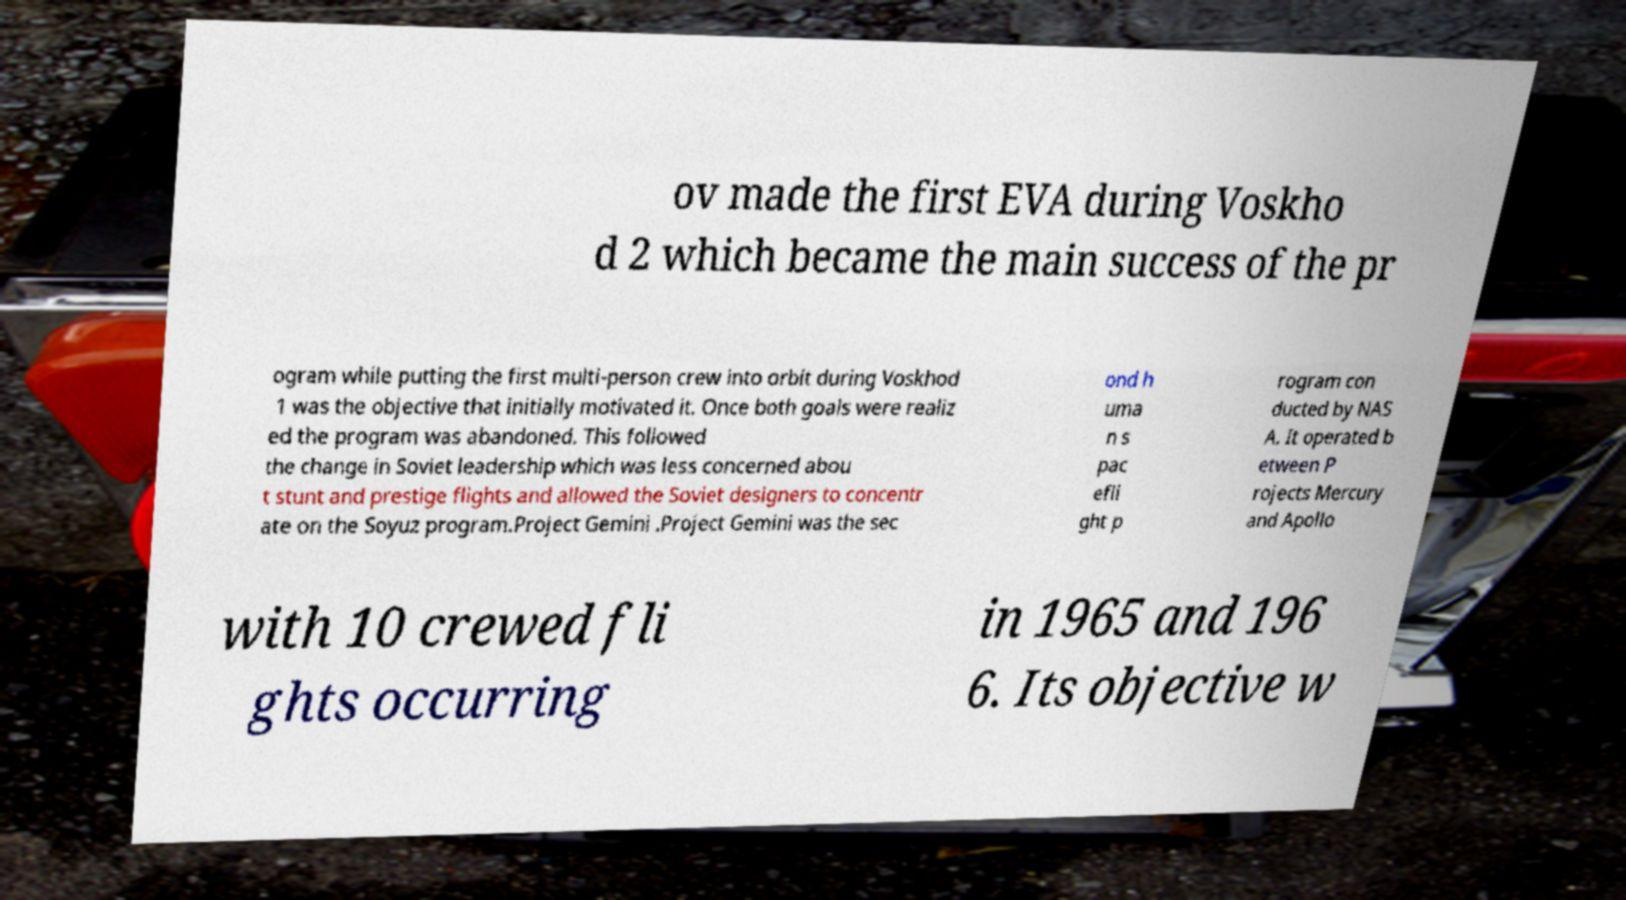For documentation purposes, I need the text within this image transcribed. Could you provide that? ov made the first EVA during Voskho d 2 which became the main success of the pr ogram while putting the first multi-person crew into orbit during Voskhod 1 was the objective that initially motivated it. Once both goals were realiz ed the program was abandoned. This followed the change in Soviet leadership which was less concerned abou t stunt and prestige flights and allowed the Soviet designers to concentr ate on the Soyuz program.Project Gemini .Project Gemini was the sec ond h uma n s pac efli ght p rogram con ducted by NAS A. It operated b etween P rojects Mercury and Apollo with 10 crewed fli ghts occurring in 1965 and 196 6. Its objective w 